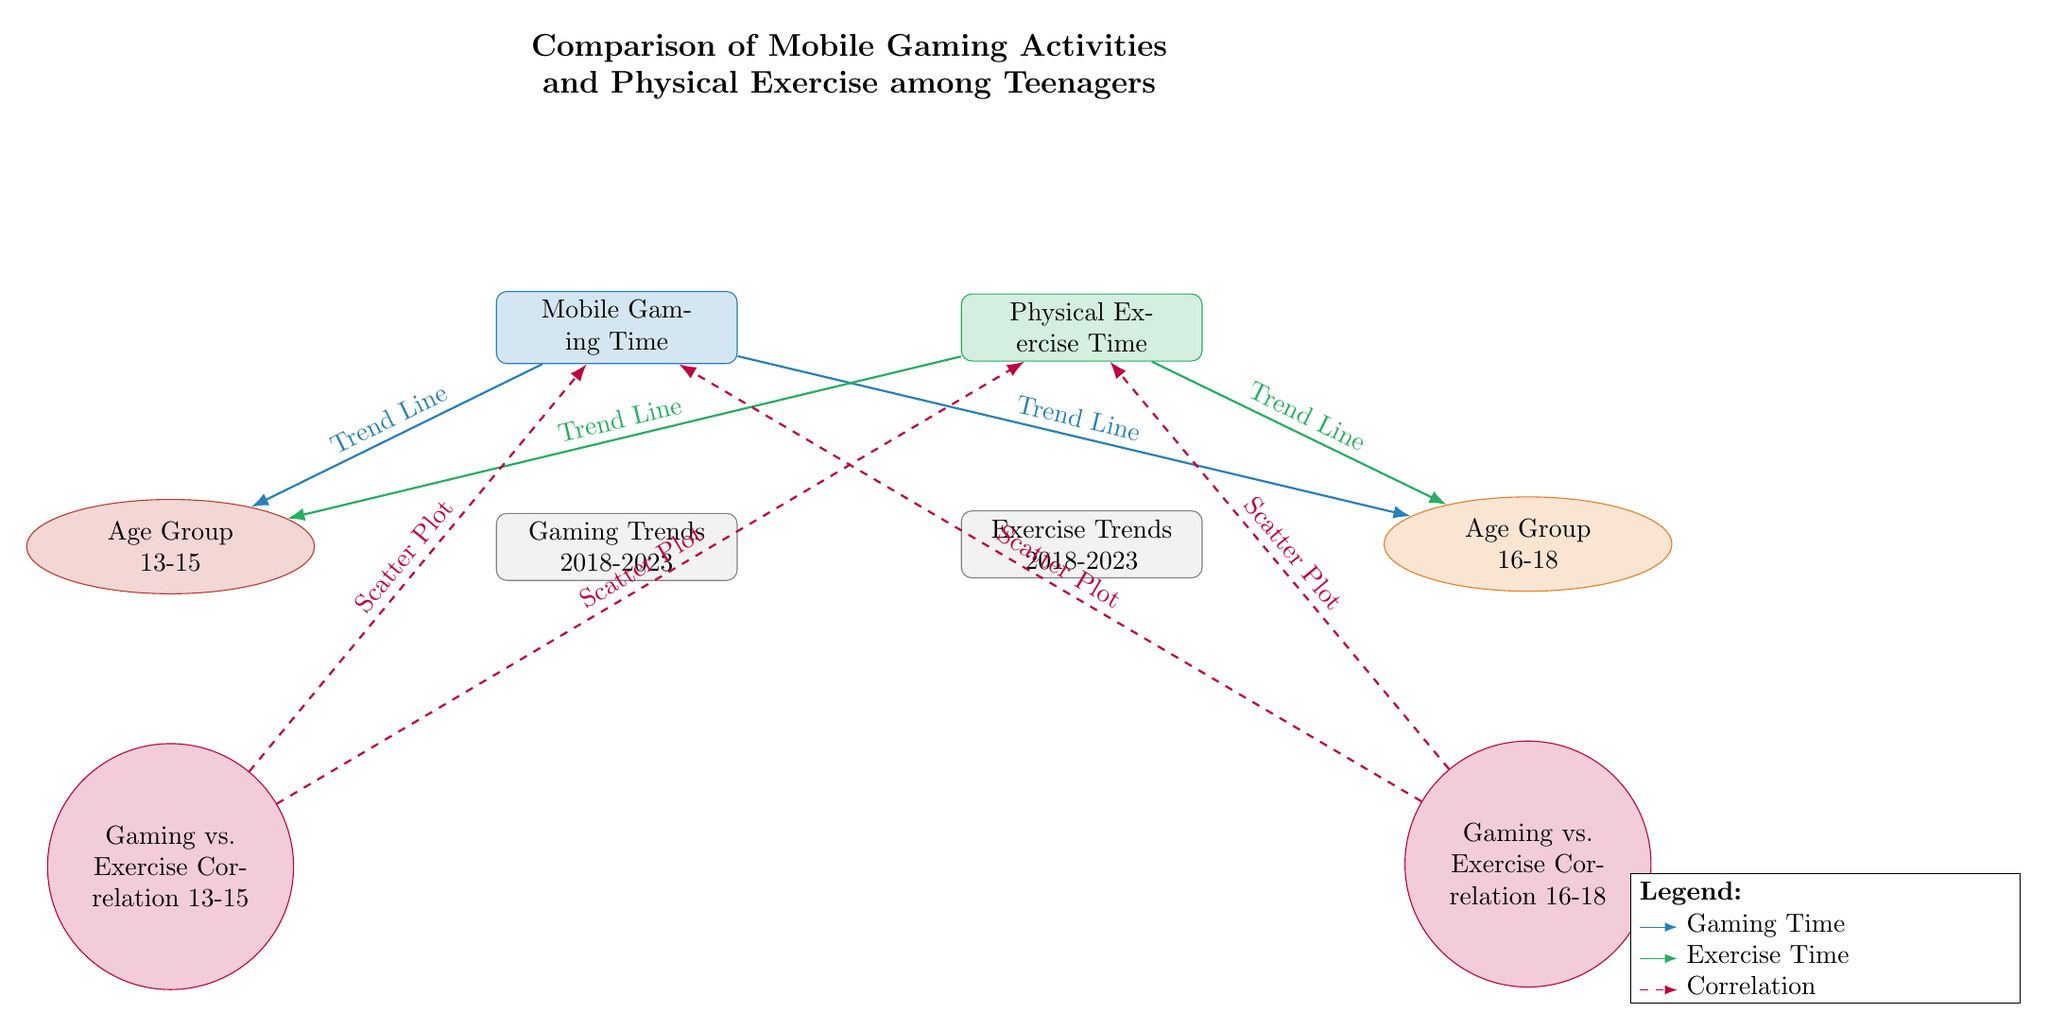What are the two main categories represented in the diagram? The diagram describes two primary categories, "Mobile Gaming Time" and "Physical Exercise Time," represented by rectangles. These are the focal points of the comparison.
Answer: Mobile Gaming Time, Physical Exercise Time How many age groups are featured in this diagram? The diagram presents two distinct age groups: "Age Group 13-15" and "Age Group 16-18," shown as ellipses. This indicates the demographic focus of the data.
Answer: 2 What trend is depicted by the arrows leading to the age group "Age Group 13-15"? The trend lines from "Mobile Gaming Time" and "Physical Exercise Time" towards "Age Group 13-15" illustrate how these behaviors change over time for this specific demographic.
Answer: Trend Line Which type of correlation visualization is indicated for the "Age Group 16-18"? The dashed arrow connecting "Gaming vs. Exercise Correlation 16-18" to both "Mobile Gaming Time" and "Physical Exercise Time" represents a scatter plot, indicating the relationship between the two activities for this age group.
Answer: Scatter Plot Explain the relationship between gaming time and physical exercise for both age groups. Each age group's node (13-15 and 16-18) is connected to both "Mobile Gaming Time" and "Physical Exercise Time," suggesting that trends in gaming may correlate with exercise habits across different ages, indicating the analysis of their relationship.
Answer: Correlation What color represents physical exercise in the diagram? The rectangle labeled "Physical Exercise Time" is filled with a green shade, which visually distinguishes it from other elements, highlighting exercise activity.
Answer: Green How does the illustration indicate trends from 2018 to 2023? The rectangles labeled "Gaming Trends 2018-2023" and "Exercise Trends 2018-2023" directly beneath the gaming and exercise activities provide a time frame for analyzing behavioral changes over these years.
Answer: 2018-2023 What does the legend in the diagram signify? The legend offers explanations for the color codings and styles of the arrows, clarifying their meanings for gaming time (blue), exercise time (green), and correlation (purple, dashed), essential for understanding the diagram's components.
Answer: Legend What type of lines connect the correlation nodes to the gaming and exercise activities? The correlation visualizations are indicated by dashed purple lines connecting the correlation nodes to the main activities, which emphasizes the nature of the data displayed.
Answer: Dashed Lines 